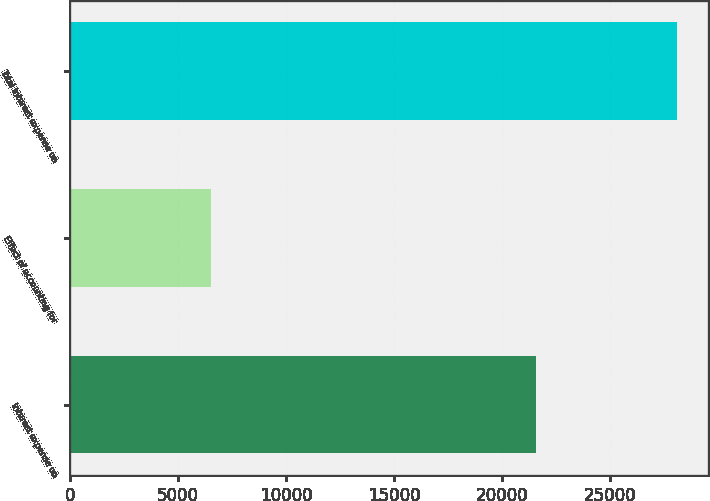Convert chart to OTSL. <chart><loc_0><loc_0><loc_500><loc_500><bar_chart><fcel>Interest expense on<fcel>Effect of accounting for<fcel>Total interest expense on<nl><fcel>21574<fcel>6536<fcel>28110<nl></chart> 